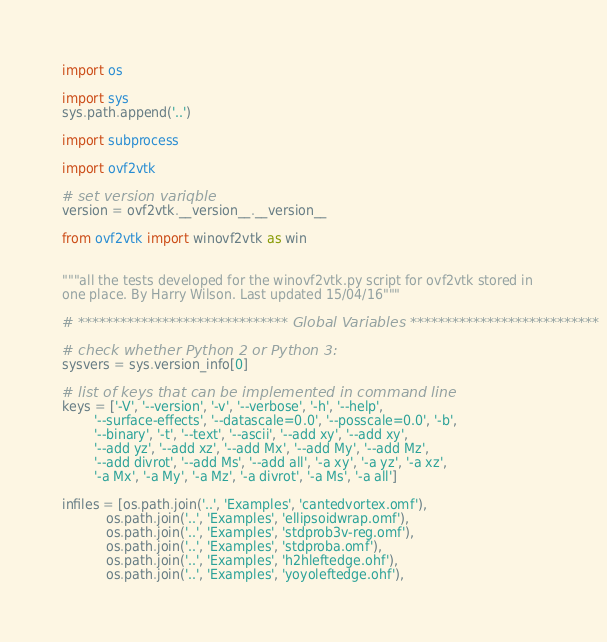<code> <loc_0><loc_0><loc_500><loc_500><_Python_>import os

import sys
sys.path.append('..')

import subprocess

import ovf2vtk

# set version variqble
version = ovf2vtk.__version__.__version__

from ovf2vtk import winovf2vtk as win


"""all the tests developed for the winovf2vtk.py script for ovf2vtk stored in
one place. By Harry Wilson. Last updated 15/04/16"""

# ****************************** Global Variables ***************************

# check whether Python 2 or Python 3:
sysvers = sys.version_info[0]

# list of keys that can be implemented in command line
keys = ['-V', '--version', '-v', '--verbose', '-h', '--help',
        '--surface-effects', '--datascale=0.0', '--posscale=0.0', '-b',
        '--binary', '-t', '--text', '--ascii', '--add xy', '--add xy',
        '--add yz', '--add xz', '--add Mx', '--add My', '--add Mz',
        '--add divrot', '--add Ms', '--add all', '-a xy', '-a yz', '-a xz',
        '-a Mx', '-a My', '-a Mz', '-a divrot', '-a Ms', '-a all']

infiles = [os.path.join('..', 'Examples', 'cantedvortex.omf'),
           os.path.join('..', 'Examples', 'ellipsoidwrap.omf'),
           os.path.join('..', 'Examples', 'stdprob3v-reg.omf'),
           os.path.join('..', 'Examples', 'stdproba.omf'),
           os.path.join('..', 'Examples', 'h2hleftedge.ohf'),
           os.path.join('..', 'Examples', 'yoyoleftedge.ohf'),</code> 